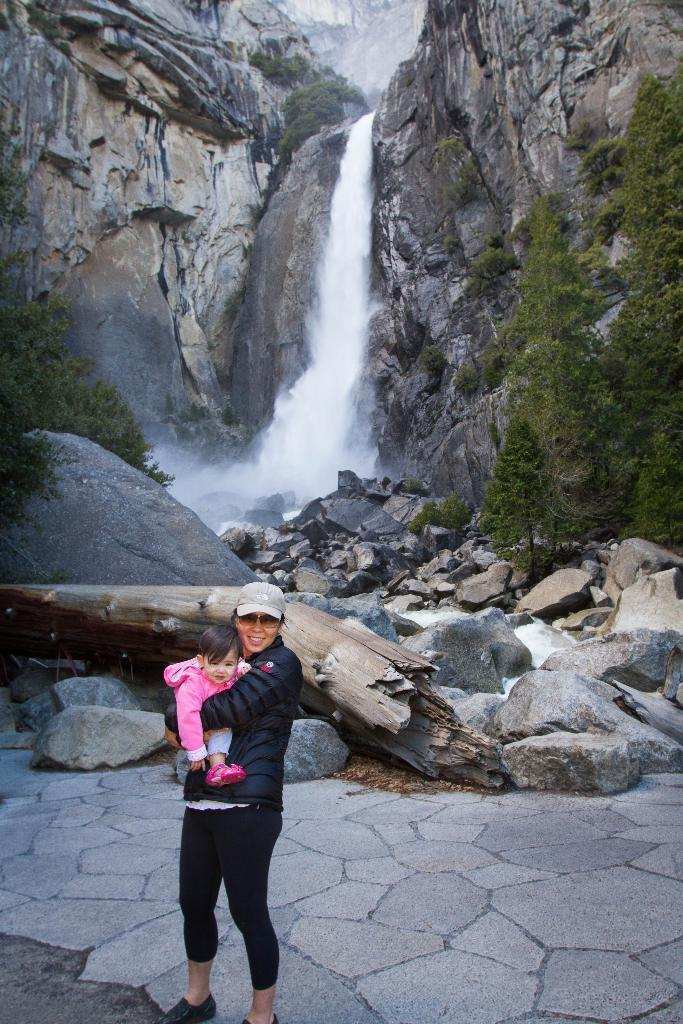What is the woman doing in the image? The woman is carrying a baby in the image. What type of terrain is visible behind the woman? There are rocks visible behind the woman. What can be seen in the distance in the image? There are trees, a waterfall, and mountains in the background of the image. Where is the hydrant located in the image? There is no hydrant present in the image. What type of clam can be seen near the waterfall in the image? There are no clams present in the image; it features a woman carrying a baby and a natural landscape. 